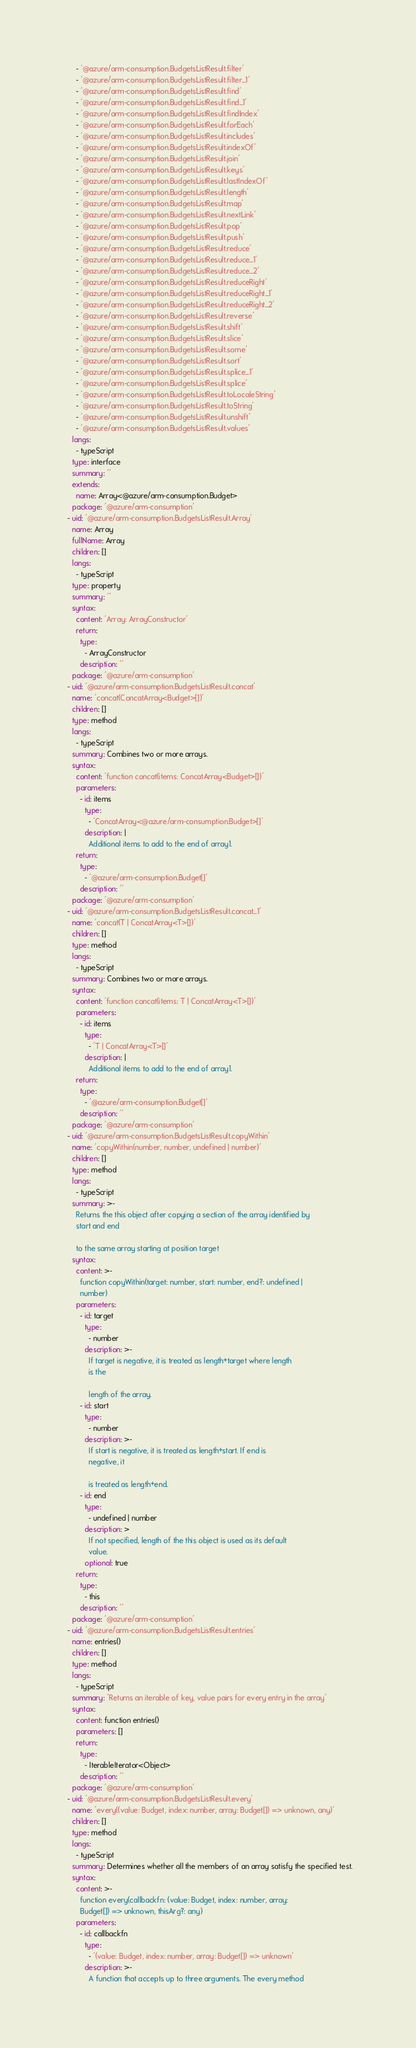<code> <loc_0><loc_0><loc_500><loc_500><_YAML_>      - '@azure/arm-consumption.BudgetsListResult.filter'
      - '@azure/arm-consumption.BudgetsListResult.filter_1'
      - '@azure/arm-consumption.BudgetsListResult.find'
      - '@azure/arm-consumption.BudgetsListResult.find_1'
      - '@azure/arm-consumption.BudgetsListResult.findIndex'
      - '@azure/arm-consumption.BudgetsListResult.forEach'
      - '@azure/arm-consumption.BudgetsListResult.includes'
      - '@azure/arm-consumption.BudgetsListResult.indexOf'
      - '@azure/arm-consumption.BudgetsListResult.join'
      - '@azure/arm-consumption.BudgetsListResult.keys'
      - '@azure/arm-consumption.BudgetsListResult.lastIndexOf'
      - '@azure/arm-consumption.BudgetsListResult.length'
      - '@azure/arm-consumption.BudgetsListResult.map'
      - '@azure/arm-consumption.BudgetsListResult.nextLink'
      - '@azure/arm-consumption.BudgetsListResult.pop'
      - '@azure/arm-consumption.BudgetsListResult.push'
      - '@azure/arm-consumption.BudgetsListResult.reduce'
      - '@azure/arm-consumption.BudgetsListResult.reduce_1'
      - '@azure/arm-consumption.BudgetsListResult.reduce_2'
      - '@azure/arm-consumption.BudgetsListResult.reduceRight'
      - '@azure/arm-consumption.BudgetsListResult.reduceRight_1'
      - '@azure/arm-consumption.BudgetsListResult.reduceRight_2'
      - '@azure/arm-consumption.BudgetsListResult.reverse'
      - '@azure/arm-consumption.BudgetsListResult.shift'
      - '@azure/arm-consumption.BudgetsListResult.slice'
      - '@azure/arm-consumption.BudgetsListResult.some'
      - '@azure/arm-consumption.BudgetsListResult.sort'
      - '@azure/arm-consumption.BudgetsListResult.splice_1'
      - '@azure/arm-consumption.BudgetsListResult.splice'
      - '@azure/arm-consumption.BudgetsListResult.toLocaleString'
      - '@azure/arm-consumption.BudgetsListResult.toString'
      - '@azure/arm-consumption.BudgetsListResult.unshift'
      - '@azure/arm-consumption.BudgetsListResult.values'
    langs:
      - typeScript
    type: interface
    summary: ''
    extends:
      name: Array<@azure/arm-consumption.Budget>
    package: '@azure/arm-consumption'
  - uid: '@azure/arm-consumption.BudgetsListResult.Array'
    name: Array
    fullName: Array
    children: []
    langs:
      - typeScript
    type: property
    summary: ''
    syntax:
      content: 'Array: ArrayConstructor'
      return:
        type:
          - ArrayConstructor
        description: ''
    package: '@azure/arm-consumption'
  - uid: '@azure/arm-consumption.BudgetsListResult.concat'
    name: 'concat(ConcatArray<Budget>[])'
    children: []
    type: method
    langs:
      - typeScript
    summary: Combines two or more arrays.
    syntax:
      content: 'function concat(items: ConcatArray<Budget>[])'
      parameters:
        - id: items
          type:
            - 'ConcatArray<@azure/arm-consumption.Budget>[]'
          description: |
            Additional items to add to the end of array1.
      return:
        type:
          - '@azure/arm-consumption.Budget[]'
        description: ''
    package: '@azure/arm-consumption'
  - uid: '@azure/arm-consumption.BudgetsListResult.concat_1'
    name: 'concat(T | ConcatArray<T>[])'
    children: []
    type: method
    langs:
      - typeScript
    summary: Combines two or more arrays.
    syntax:
      content: 'function concat(items: T | ConcatArray<T>[])'
      parameters:
        - id: items
          type:
            - 'T | ConcatArray<T>[]'
          description: |
            Additional items to add to the end of array1.
      return:
        type:
          - '@azure/arm-consumption.Budget[]'
        description: ''
    package: '@azure/arm-consumption'
  - uid: '@azure/arm-consumption.BudgetsListResult.copyWithin'
    name: 'copyWithin(number, number, undefined | number)'
    children: []
    type: method
    langs:
      - typeScript
    summary: >-
      Returns the this object after copying a section of the array identified by
      start and end

      to the same array starting at position target
    syntax:
      content: >-
        function copyWithin(target: number, start: number, end?: undefined |
        number)
      parameters:
        - id: target
          type:
            - number
          description: >-
            If target is negative, it is treated as length+target where length
            is the

            length of the array.
        - id: start
          type:
            - number
          description: >-
            If start is negative, it is treated as length+start. If end is
            negative, it

            is treated as length+end.
        - id: end
          type:
            - undefined | number
          description: >
            If not specified, length of the this object is used as its default
            value.
          optional: true
      return:
        type:
          - this
        description: ''
    package: '@azure/arm-consumption'
  - uid: '@azure/arm-consumption.BudgetsListResult.entries'
    name: entries()
    children: []
    type: method
    langs:
      - typeScript
    summary: 'Returns an iterable of key, value pairs for every entry in the array'
    syntax:
      content: function entries()
      parameters: []
      return:
        type:
          - IterableIterator<Object>
        description: ''
    package: '@azure/arm-consumption'
  - uid: '@azure/arm-consumption.BudgetsListResult.every'
    name: 'every((value: Budget, index: number, array: Budget[]) => unknown, any)'
    children: []
    type: method
    langs:
      - typeScript
    summary: Determines whether all the members of an array satisfy the specified test.
    syntax:
      content: >-
        function every(callbackfn: (value: Budget, index: number, array:
        Budget[]) => unknown, thisArg?: any)
      parameters:
        - id: callbackfn
          type:
            - '(value: Budget, index: number, array: Budget[]) => unknown'
          description: >-
            A function that accepts up to three arguments. The every method</code> 